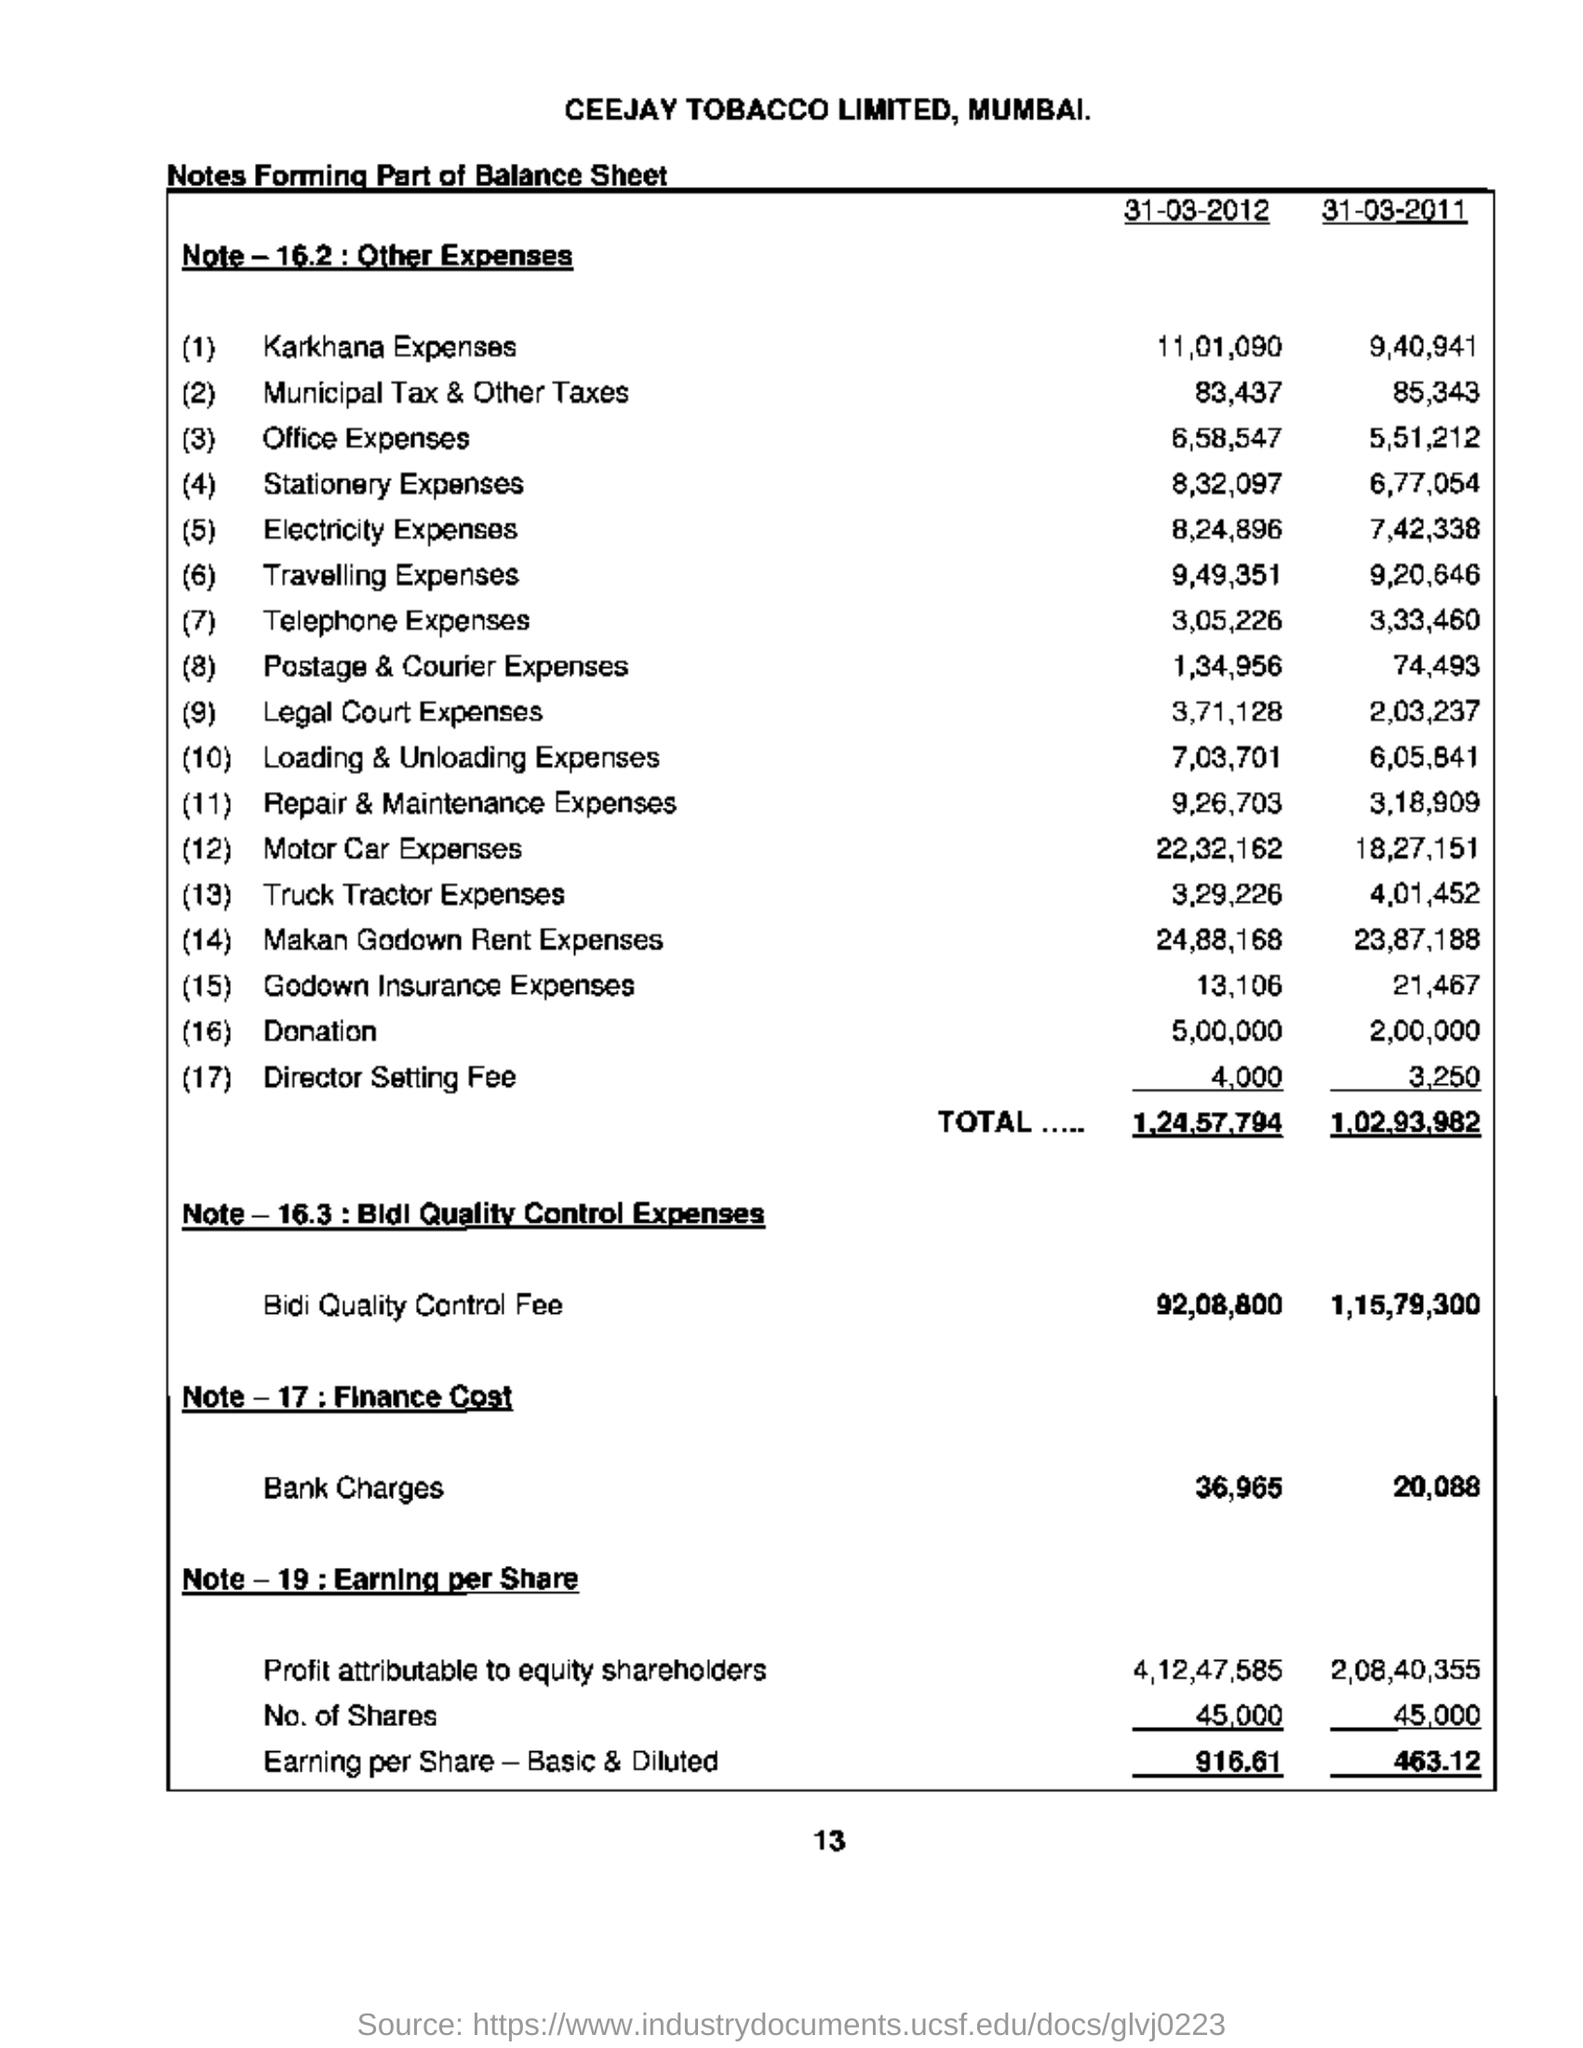List a handful of essential elements in this visual. On March 31, 2012, the bank charges totaled 36,965. The office expenses for the date of March 31, 2012, were 6,58,547. The donation amount for March 31, 2012, was 5,00,000. The expenses for Karkhana on March 31, 2012, were 11,01,090. On March 31, 2011, the donation amount was 2,00,000. 